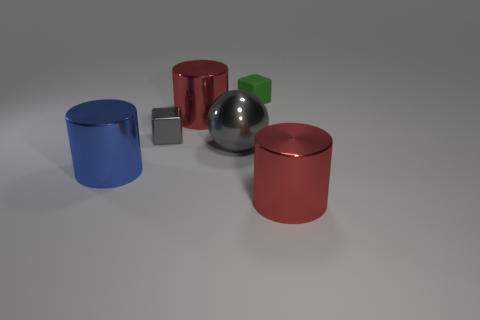Add 4 large gray shiny spheres. How many objects exist? 10 Subtract all balls. How many objects are left? 5 Subtract all small brown matte objects. Subtract all tiny gray shiny objects. How many objects are left? 5 Add 5 blue objects. How many blue objects are left? 6 Add 2 large metallic objects. How many large metallic objects exist? 6 Subtract 0 brown spheres. How many objects are left? 6 